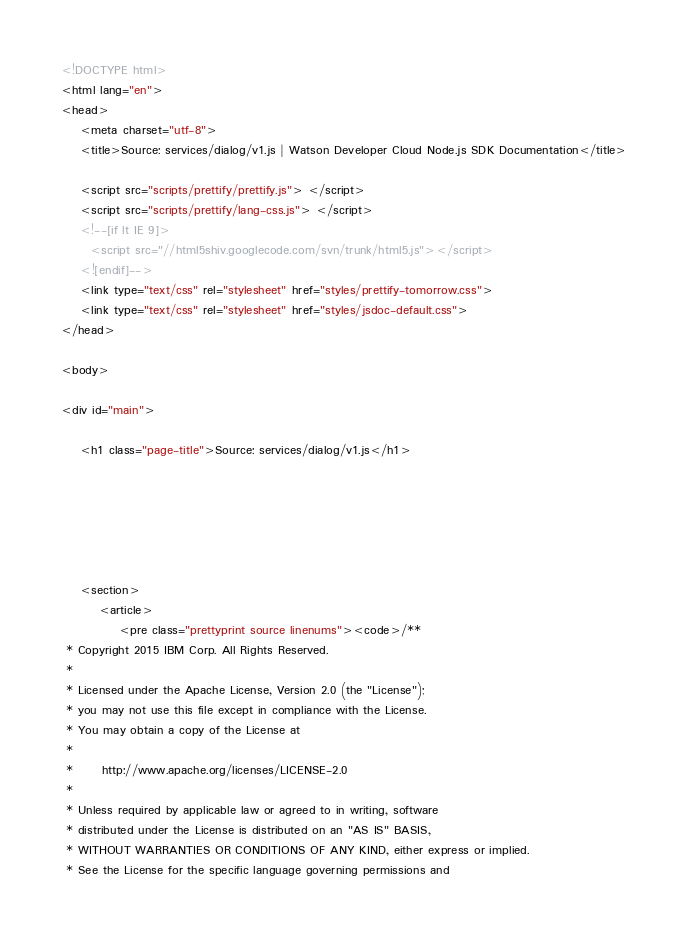<code> <loc_0><loc_0><loc_500><loc_500><_HTML_><!DOCTYPE html>
<html lang="en">
<head>
    <meta charset="utf-8">
    <title>Source: services/dialog/v1.js | Watson Developer Cloud Node.js SDK Documentation</title>

    <script src="scripts/prettify/prettify.js"> </script>
    <script src="scripts/prettify/lang-css.js"> </script>
    <!--[if lt IE 9]>
      <script src="//html5shiv.googlecode.com/svn/trunk/html5.js"></script>
    <![endif]-->
    <link type="text/css" rel="stylesheet" href="styles/prettify-tomorrow.css">
    <link type="text/css" rel="stylesheet" href="styles/jsdoc-default.css">
</head>

<body>

<div id="main">

    <h1 class="page-title">Source: services/dialog/v1.js</h1>

    



    
    <section>
        <article>
            <pre class="prettyprint source linenums"><code>/**
 * Copyright 2015 IBM Corp. All Rights Reserved.
 *
 * Licensed under the Apache License, Version 2.0 (the "License");
 * you may not use this file except in compliance with the License.
 * You may obtain a copy of the License at
 *
 *      http://www.apache.org/licenses/LICENSE-2.0
 *
 * Unless required by applicable law or agreed to in writing, software
 * distributed under the License is distributed on an "AS IS" BASIS,
 * WITHOUT WARRANTIES OR CONDITIONS OF ANY KIND, either express or implied.
 * See the License for the specific language governing permissions and</code> 